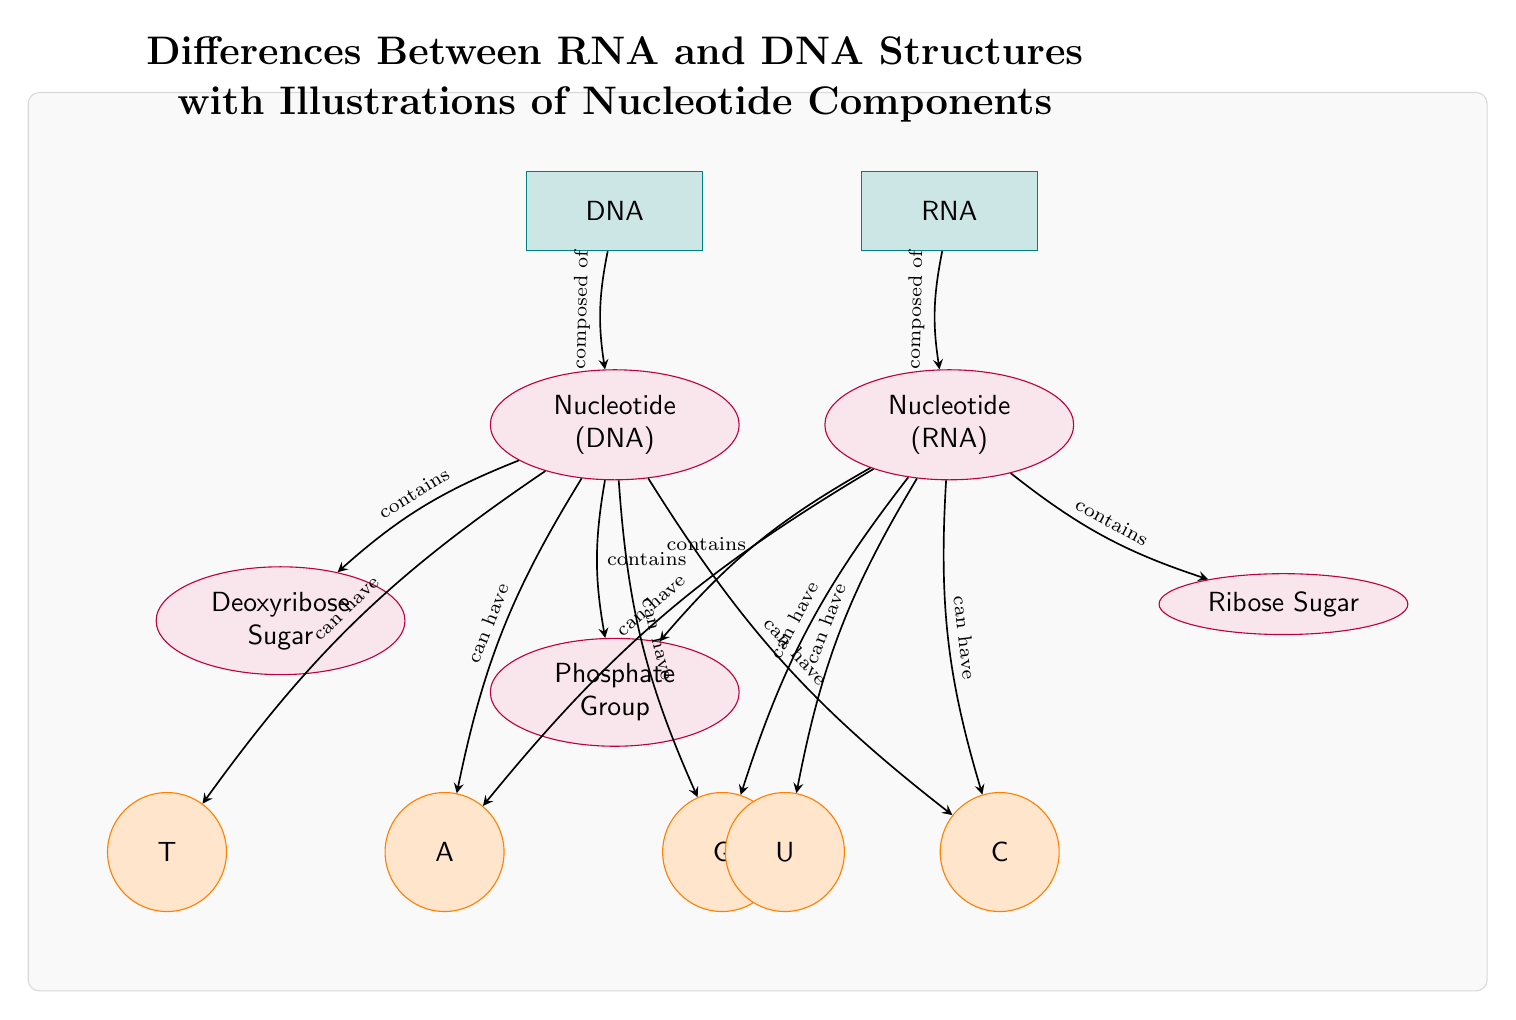What are the two main entities in the diagram? The diagram shows two main entities labeled as DNA and RNA, which are clearly indicated at the top of the diagram.
Answer: DNA, RNA How many types of sugars are illustrated in the diagram? The diagram illustrates two types of sugars: Deoxyribose Sugar for DNA and Ribose Sugar for RNA.
Answer: 2 Which base is unique to RNA? The base labeled U is the only base that is uniquely associated with RNA, as it does not appear in the DNA section.
Answer: U What does the Phosphate Group connect to in both DNA and RNA nucleotides? The Phosphate Group is portrayed as a common component that connects to both Nucleotide (DNA) and Nucleotide (RNA), indicating it is present in both structures.
Answer: Nucleotide (DNA), Nucleotide (RNA) Which bases can DNA contain? DNA can contain the bases A, T, G, and C, which are listed as components connected to the Nucleotide (DNA) in the diagram.
Answer: A, T, G, C Why does RNA not have a Thymine base? In the diagram, the presence of base U instead of T for RNA indicates that Thymine is not a component of RNA nucleotides; thus, Uracil substitutes it.
Answer: Thymine What type of connection is indicated by the arrows in the diagram? The arrows illustrate directed relationships or connections between different components and entities, indicating how they relate to each other within the structure.
Answer: Directed relationships Which molecule is composed of sugar, phosphate, and a base? The Nucleotide (DNA) and Nucleotide (RNA) are both described in the diagram as being composed of these three components: sugar, phosphate, and a base.
Answer: Nucleotide (DNA), Nucleotide (RNA) 